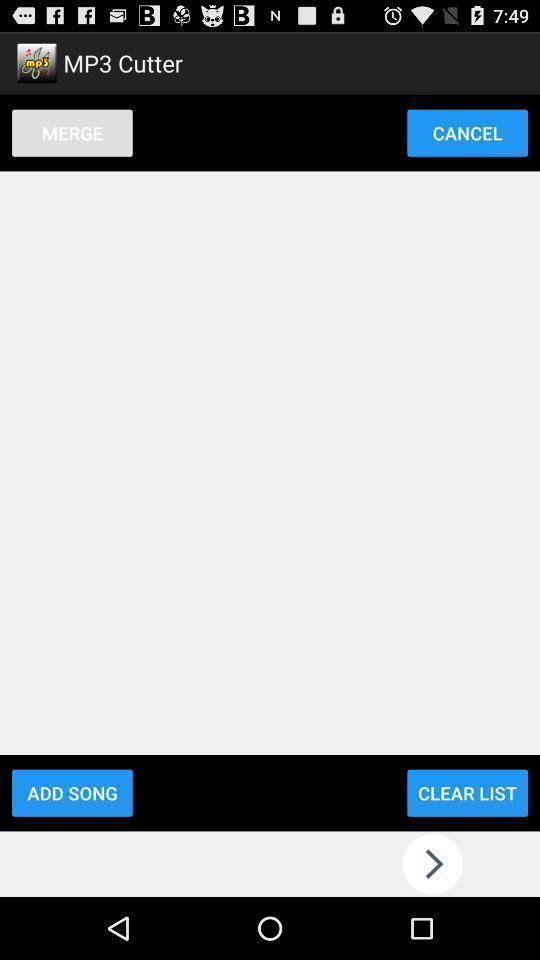Give me a summary of this screen capture. Screen shows a merge cutter. 